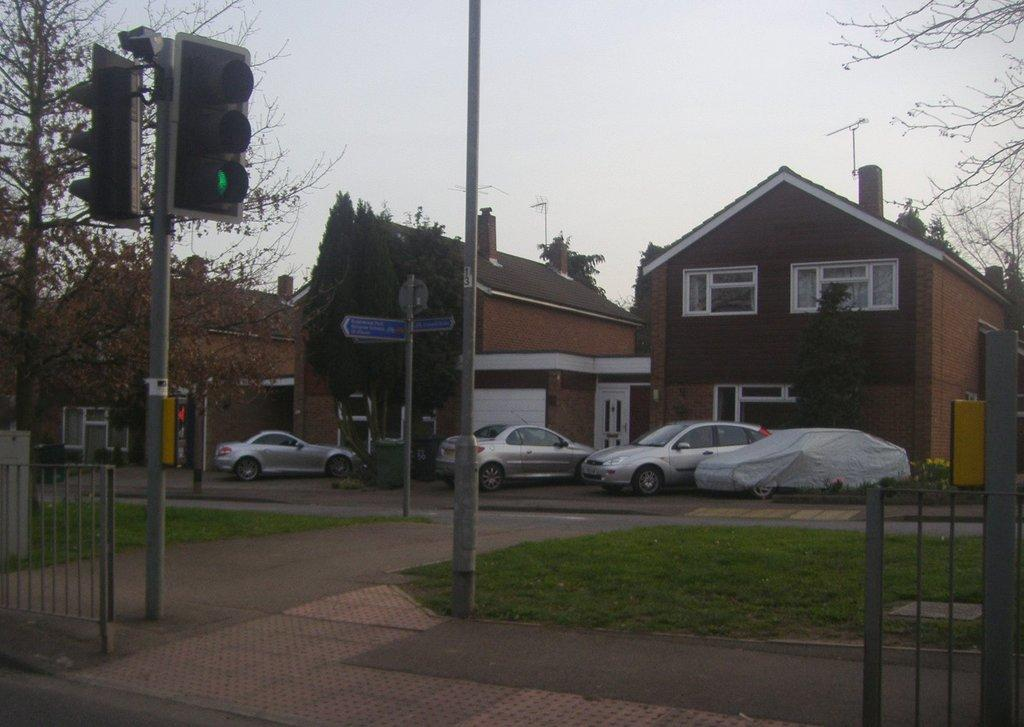What can be seen parked in front of the houses in the image? There are cars parked in front of the houses in the image. What type of vegetation is visible in the image? There are trees visible in the image. What type of surface is present in the image? There is grass on the surface in the image. What device is present to regulate traffic in the image? There is a traffic signal in the image. What type of drug can be seen growing in the grass in the image? There is no drug present in the image; it features cars parked in front of houses, trees, grass, and a traffic signal. What type of produce is visible in the image? There is no produce visible in the image. 